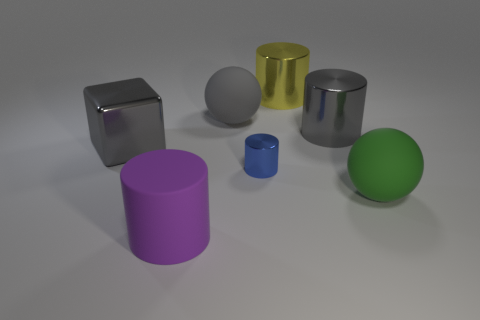Is there any other thing that is the same size as the blue metallic cylinder?
Provide a succinct answer. No. Is the number of big purple cylinders that are behind the big gray metal block less than the number of small blue metal cubes?
Ensure brevity in your answer.  No. There is a large gray metal thing left of the large yellow cylinder that is right of the tiny blue object; what is its shape?
Your answer should be compact. Cube. What is the color of the rubber cylinder?
Offer a terse response. Purple. How many other objects are there of the same size as the blue cylinder?
Ensure brevity in your answer.  0. There is a object that is on the left side of the blue thing and in front of the tiny cylinder; what is its material?
Provide a succinct answer. Rubber. Does the metal cylinder behind the gray metallic cylinder have the same size as the large purple rubber object?
Offer a very short reply. Yes. What number of big cylinders are in front of the big yellow thing and behind the big purple rubber cylinder?
Your response must be concise. 1. What number of large gray cylinders are to the left of the gray metallic object that is right of the large cylinder in front of the tiny shiny cylinder?
Keep it short and to the point. 0. There is a ball that is the same color as the large metallic block; what is its size?
Offer a very short reply. Large. 